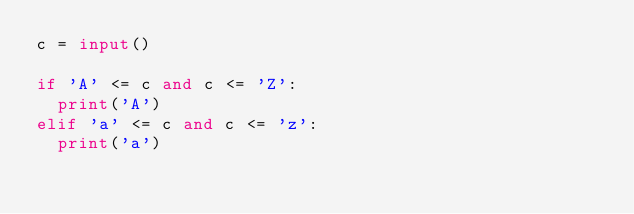Convert code to text. <code><loc_0><loc_0><loc_500><loc_500><_Python_>c = input()

if 'A' <= c and c <= 'Z':
  print('A')
elif 'a' <= c and c <= 'z':
  print('a')</code> 